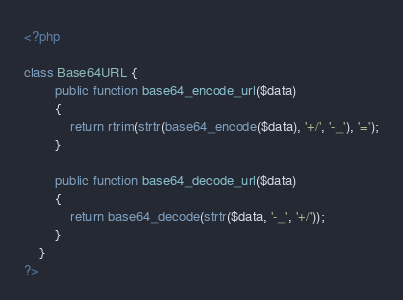<code> <loc_0><loc_0><loc_500><loc_500><_PHP_><?php

class Base64URL {
	    public function base64_encode_url($data) 
	    {
	    	return rtrim(strtr(base64_encode($data), '+/', '-_'), '=');
		}

		public function base64_decode_url($data) 
		{
	    	return base64_decode(strtr($data, '-_', '+/'));
		}
	}
?></code> 